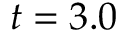Convert formula to latex. <formula><loc_0><loc_0><loc_500><loc_500>t = 3 . 0</formula> 